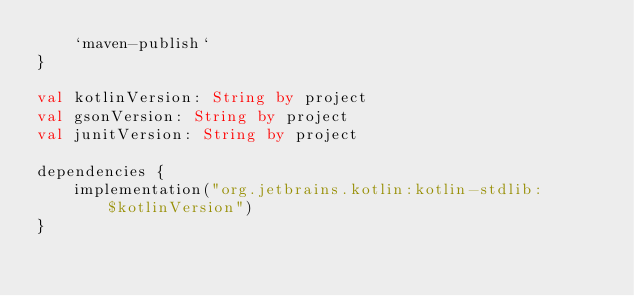<code> <loc_0><loc_0><loc_500><loc_500><_Kotlin_>    `maven-publish`
}

val kotlinVersion: String by project
val gsonVersion: String by project
val junitVersion: String by project

dependencies {
    implementation("org.jetbrains.kotlin:kotlin-stdlib:$kotlinVersion")
}
</code> 